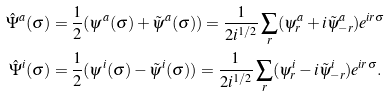<formula> <loc_0><loc_0><loc_500><loc_500>\hat { \Psi } ^ { a } ( \sigma ) & = \frac { 1 } { 2 } ( \psi ^ { a } ( \sigma ) + \tilde { \psi } ^ { a } ( \sigma ) ) = \frac { 1 } { 2 i ^ { 1 / 2 } } \sum _ { r } ( \psi _ { r } ^ { a } + i \tilde { \psi } _ { - r } ^ { a } ) e ^ { i r \sigma } \\ \hat { \Psi } ^ { i } ( \sigma ) & = \frac { 1 } { 2 } ( \psi ^ { i } ( \sigma ) - \tilde { \psi } ^ { i } ( \sigma ) ) = \frac { 1 } { 2 i ^ { 1 / 2 } } \sum _ { r } ( \psi _ { r } ^ { i } - i \tilde { \psi } _ { - r } ^ { i } ) e ^ { i r \sigma } .</formula> 